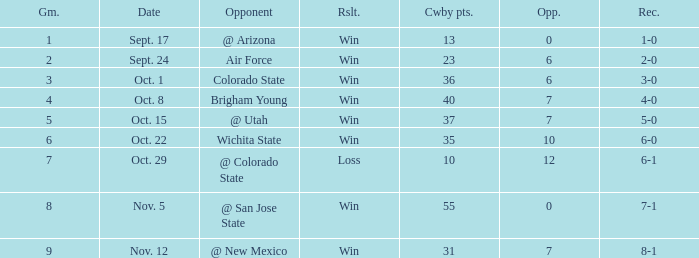What was the Cowboys' record for Nov. 5, 1966? 7-1. 